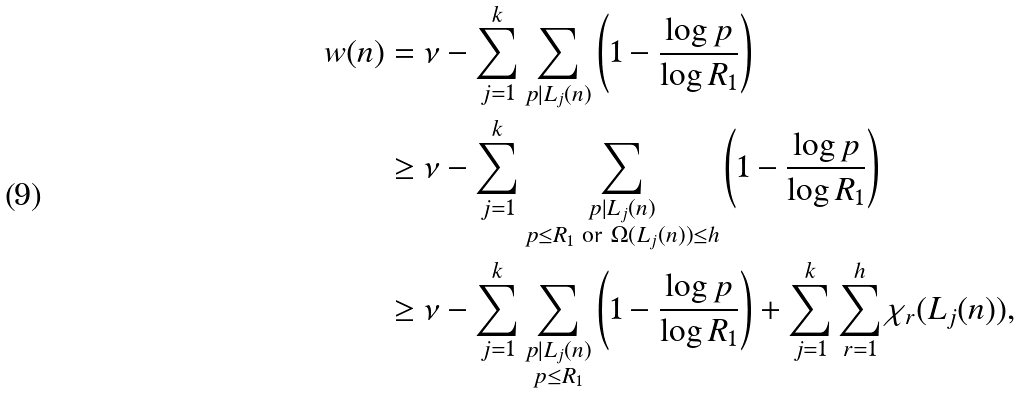Convert formula to latex. <formula><loc_0><loc_0><loc_500><loc_500>w ( n ) & = \nu - \sum _ { j = 1 } ^ { k } \sum _ { p | L _ { j } ( n ) } \left ( 1 - \frac { \log { p } } { \log { R _ { 1 } } } \right ) \\ & \geq \nu - \sum _ { j = 1 } ^ { k } \sum _ { \substack { p | L _ { j } ( n ) \\ p \leq R _ { 1 } \text { or } \Omega ( L _ { j } ( n ) ) \leq h } } \left ( 1 - \frac { \log { p } } { \log { R _ { 1 } } } \right ) \\ & \geq \nu - \sum _ { j = 1 } ^ { k } \sum _ { \substack { p | L _ { j } ( n ) \\ p \leq R _ { 1 } } } \left ( 1 - \frac { \log { p } } { \log { R _ { 1 } } } \right ) + \sum _ { j = 1 } ^ { k } \sum _ { r = 1 } ^ { h } \chi _ { r } ( L _ { j } ( n ) ) ,</formula> 